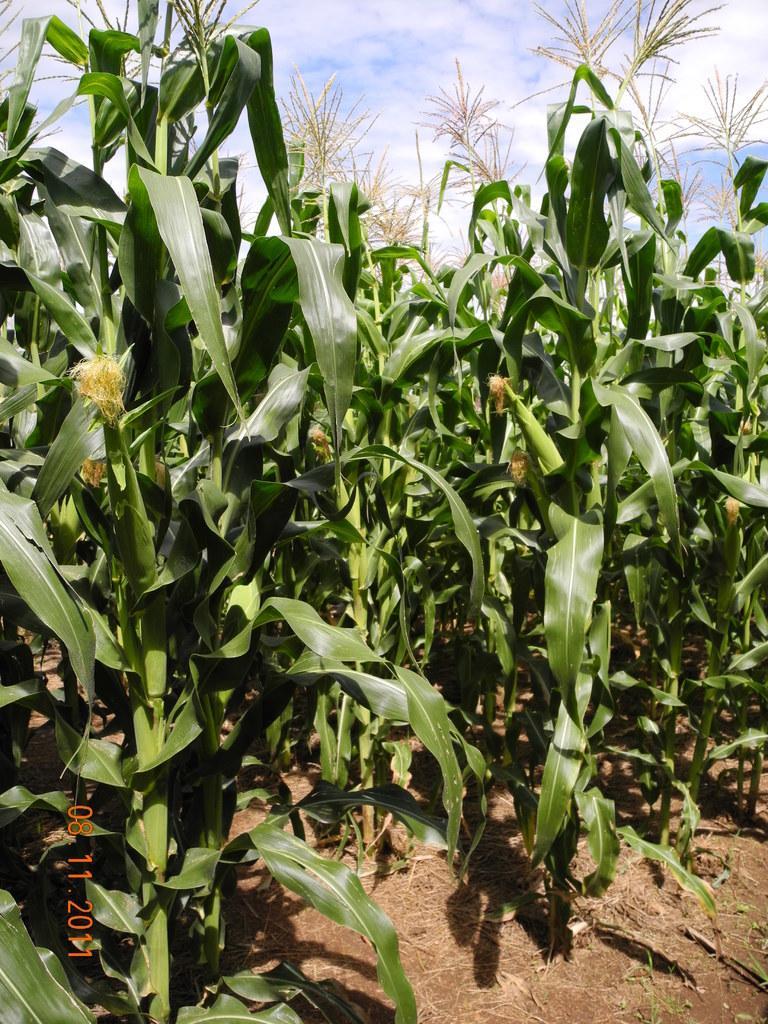Please provide a concise description of this image. There are plants. The date is mentioned at the left bottom. There is sky. 